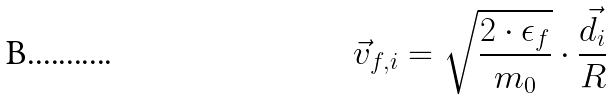<formula> <loc_0><loc_0><loc_500><loc_500>\vec { v } _ { f , i } = \sqrt { \frac { 2 \cdot \epsilon _ { f } } { m _ { 0 } } } \cdot \frac { \vec { d } _ { i } } { R }</formula> 